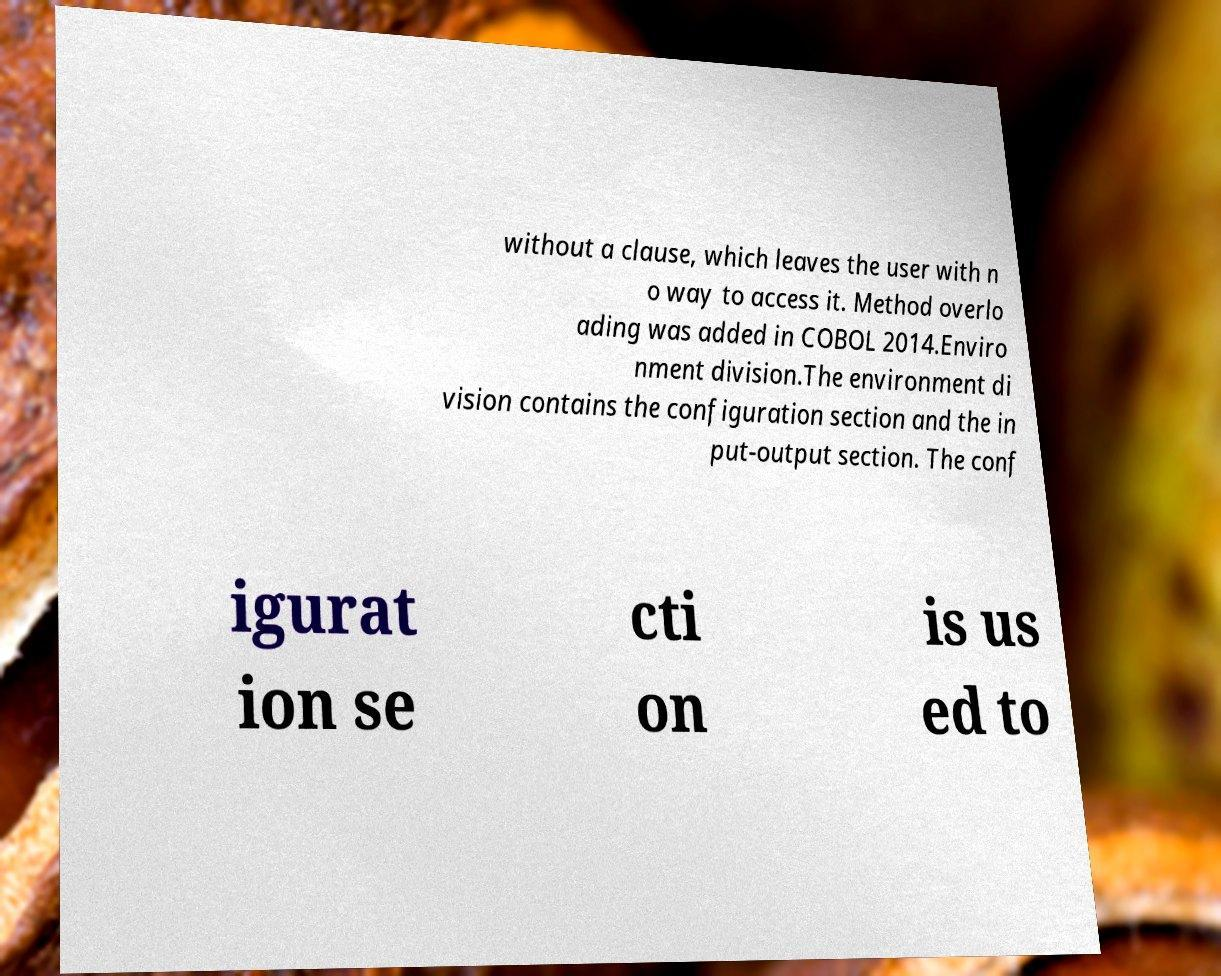Could you extract and type out the text from this image? without a clause, which leaves the user with n o way to access it. Method overlo ading was added in COBOL 2014.Enviro nment division.The environment di vision contains the configuration section and the in put-output section. The conf igurat ion se cti on is us ed to 